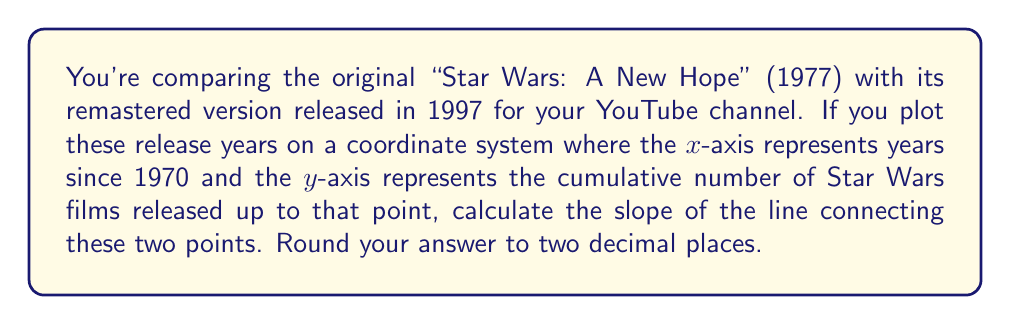Provide a solution to this math problem. Let's approach this step-by-step:

1) First, let's identify our points:
   - 1977 release: (7, 1) because it's 7 years after 1970 and it's the 1st Star Wars film
   - 1997 release: (27, 4) because it's 27 years after 1970 and by 1997, 4 Star Wars films had been released (Episodes IV, V, VI, and I)

2) The slope formula is:

   $$m = \frac{y_2 - y_1}{x_2 - x_1}$$

   Where $(x_1, y_1)$ is the first point and $(x_2, y_2)$ is the second point.

3) Let's plug in our values:

   $$m = \frac{4 - 1}{27 - 7} = \frac{3}{20}$$

4) To calculate this:
   
   $$\frac{3}{20} = 0.15$$

5) Rounding to two decimal places, we get 0.15.
Answer: $0.15$ 